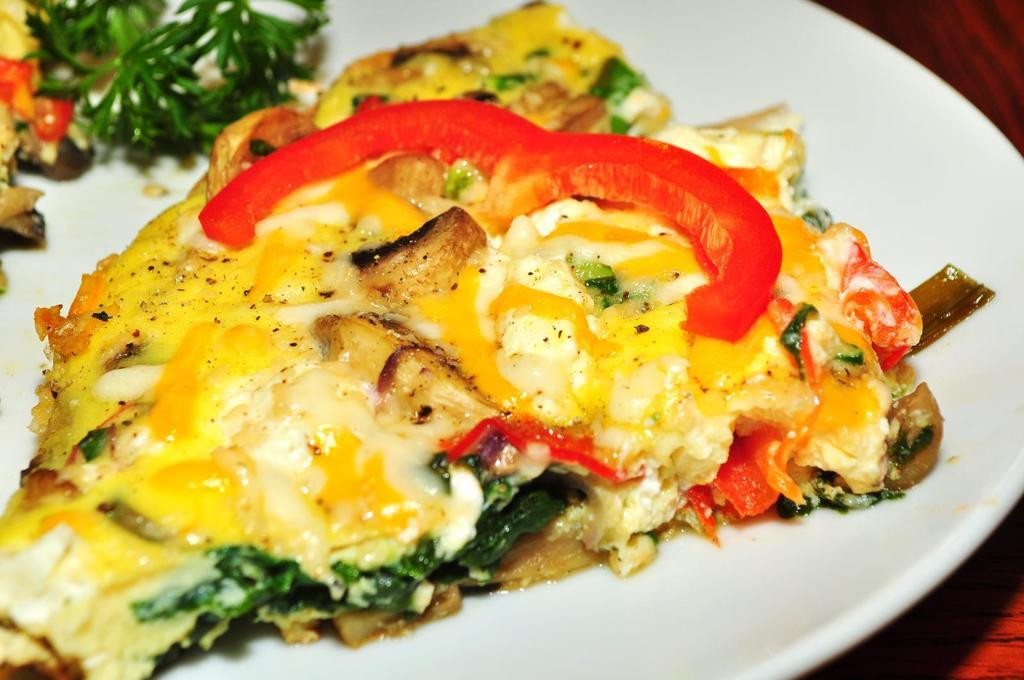What is on the plate that is visible in the image? There is a plate with food in the image, including vegetable leaves and tomato slices. What type of surface is the plate placed on in the image? The wooden surface is visible in the image. Can you hear the bells ringing in the image? There are no bells present in the image, so it is not possible to hear them ringing. 